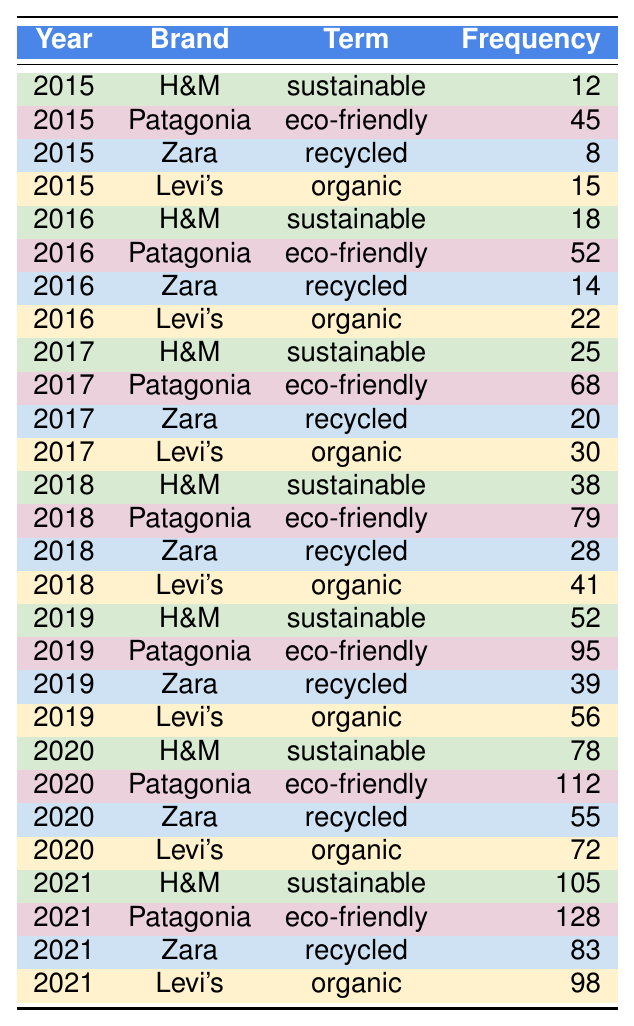What was the frequency of the term "sustainable" used by H&M in 2020? In the row corresponding to H&M for the year 2020, the frequency for the term "sustainable" is given as 78.
Answer: 78 Which brand had the highest frequency of the term "eco-friendly" in 2021? Looking at the year 2021, Patagonia has the highest frequency with 128 occurrences of the term "eco-friendly."
Answer: Patagonia What is the total frequency of the term "recycled" across all years? To find the total frequency of the term "recycled," I add the frequencies for Zara from each year: 8 + 14 + 20 + 28 + 39 + 55 + 83 = 247.
Answer: 247 Did Levi's ever use the term "organic" more than 50 times in any year? Based on the data, Levi's had frequencies of 15, 22, 30, 41, 56, 72, and 98 for the term "organic" in the respective years, and it is evident that 56 in 2019 is the highest, which is still less than 50 for some years. Therefore, Levi's did not exceed 50 in previous years.
Answer: No In which year did Patagonia see the highest increase in the frequency of the term "eco-friendly" compared to the previous year? The frequencies for Patagonia from 2015 to 2021 are 45, 52, 68, 79, 95, and 112. The increases are as follows: 7 (2015 to 2016), 16 (2016 to 2017), 11 (2017 to 2018), 16 (2018 to 2019), and 17 (2019 to 2020). The highest increase is 17 between 2020 and 2021.
Answer: 2021 What was the average frequency of the term "sustainable" for H&M from 2015 to 2021? The frequencies for H&M using "sustainable" from 2015 to 2021 are: 12, 18, 25, 38, 52, 78, 105. To calculate the average, I sum these frequencies: 12 + 18 + 25 + 38 + 52 + 78 + 105 = 328, and then divide by 7 (the number of years), producing an average of 46.86.
Answer: 46.86 Compare the frequency of the term "recycled" for Zara in 2019 and 2020. Was the frequency higher in 2020? In 2019, Zara's frequency for "recycled" was 39, while in 2020 it was 55. Since 55 is greater than 39, it indicates that the frequency increased.
Answer: Yes What was the frequency of the term "organic" for Levi's in 2021? The data shows that Levi's had a frequency of 98 for the term "organic" in the year 2021.
Answer: 98 